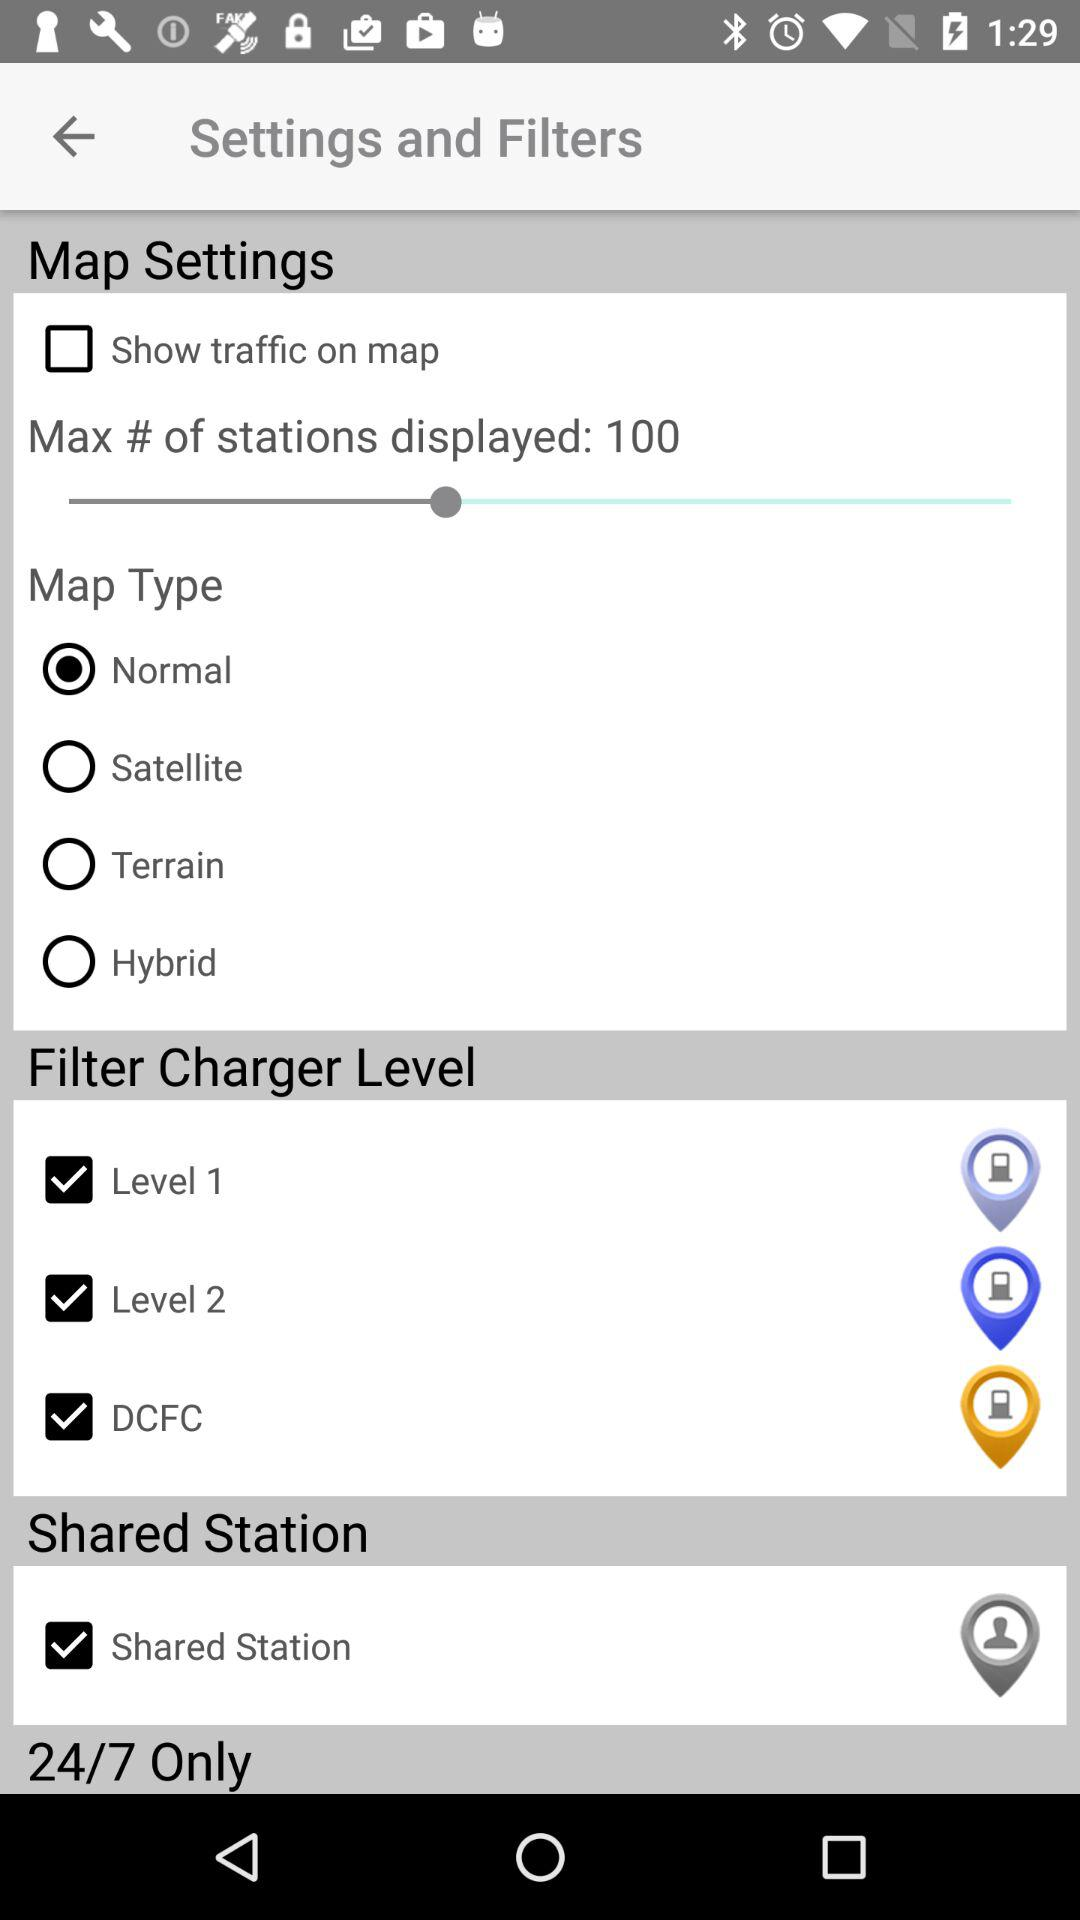What is the status of "Level 1" in the "Filter Charger Level"? The status is "on". 